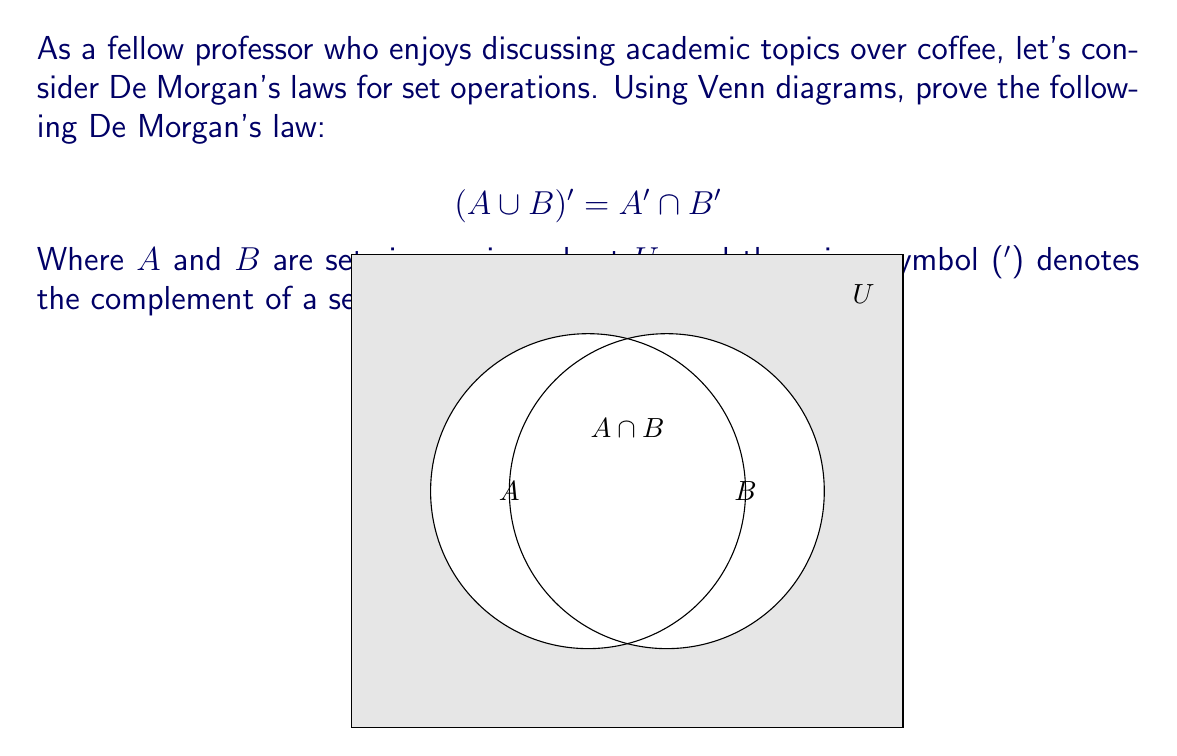Teach me how to tackle this problem. Let's prove De Morgan's law $(A \cup B)' = A' \cap B'$ using Venn diagrams:

1) First, let's visualize $(A \cup B)'$:
   - Shade the entire universal set $U$.
   - Unshade the region representing $A \cup B$.
   - The remaining shaded area is $(A \cup B)'$.

[asy]
unitsize(1cm);
import geometry;

path c1 = circle((0,0),2);
path c2 = circle((1,0),2);
path r = rectangle((-3,-3),(4,3));

fill(r,gray);
fill(c1,white);
fill(c2,white);

draw(r);
draw(c1);
draw(c2);

label("$A$",(-1,0));
label("$B$",(2,0));
label("$U$",(3.5,2.5));
label("$(A \cup B)'$",(-2.5,2.5));
[/asy]

2) Now, let's visualize $A' \cap B'$:
   - Shade the entire universal set $U$.
   - Unshade the region representing $A$.
   - Unshade the region representing $B$.
   - The remaining shaded area is $A' \cap B'$.

[asy]
unitsize(1cm);
import geometry;

path c1 = circle((0,0),2);
path c2 = circle((1,0),2);
path r = rectangle((-3,-3),(4,3));

fill(r,gray);
fill(c1,white);
fill(c2,white);

draw(r);
draw(c1);
draw(c2);

label("$A$",(-1,0));
label("$B$",(2,0));
label("$U$",(3.5,2.5));
label("$A' \cap B'$",(-2.5,2.5));
[/asy]

3) Comparing the two diagrams, we can see that the shaded regions in both cases are identical. This visual representation proves that $(A \cup B)' = A' \cap B'$.

4) To further understand this, consider the following:
   - $(A \cup B)'$ represents all elements in $U$ that are not in $A$ or $B$.
   - $A'$ represents all elements in $U$ that are not in $A$.
   - $B'$ represents all elements in $U$ that are not in $B$.
   - $A' \cap B'$ represents all elements that are neither in $A$ nor in $B$.

5) Therefore, the elements in $(A \cup B)'$ are exactly the same as the elements in $A' \cap B'$, proving the equality.
Answer: $(A \cup B)' = A' \cap B'$ is true, as demonstrated by identical shaded regions in the Venn diagrams. 